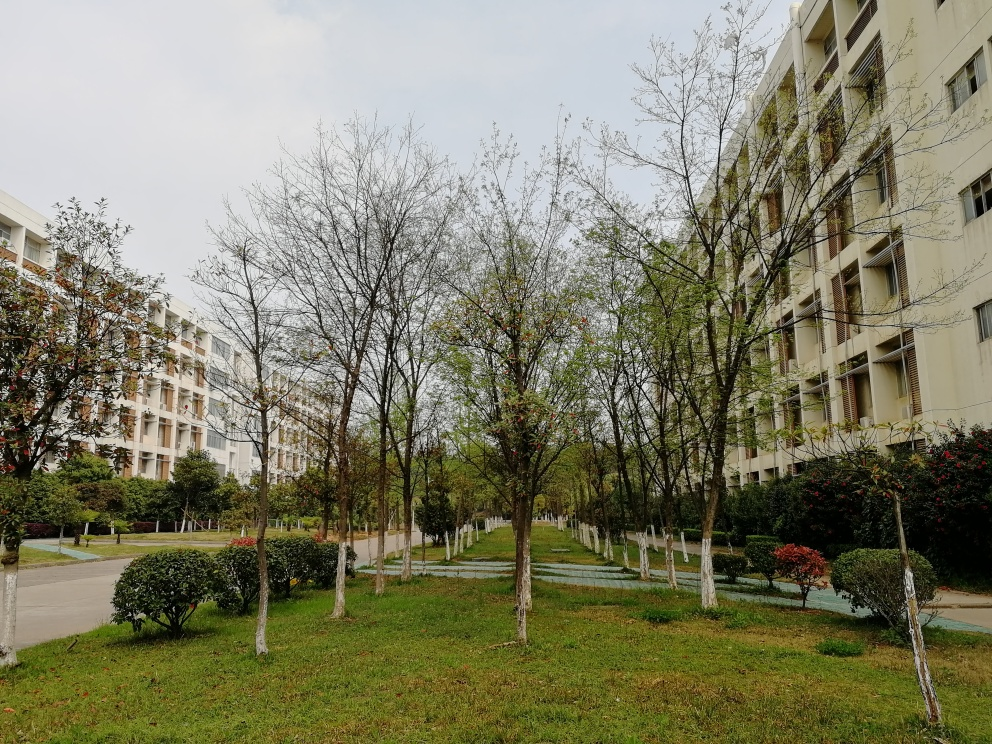How is the human activity in this area represented? Human activity is subtly indicated by the well-maintained pathways and the orderly arrangement of trees and bushes. While there are no people directly visible in the photo, these landscape features suggest regular human interaction in terms of maintenance and use of the space for leisure or transit. 